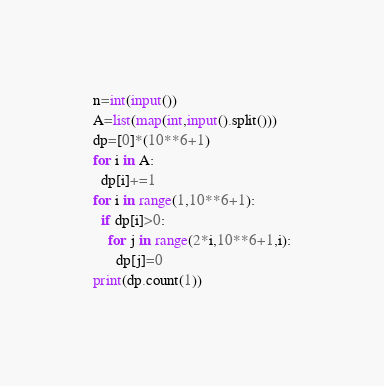<code> <loc_0><loc_0><loc_500><loc_500><_Python_>n=int(input())
A=list(map(int,input().split()))
dp=[0]*(10**6+1)
for i in A:
  dp[i]+=1
for i in range(1,10**6+1):
  if dp[i]>0:
    for j in range(2*i,10**6+1,i):
      dp[j]=0
print(dp.count(1))      </code> 